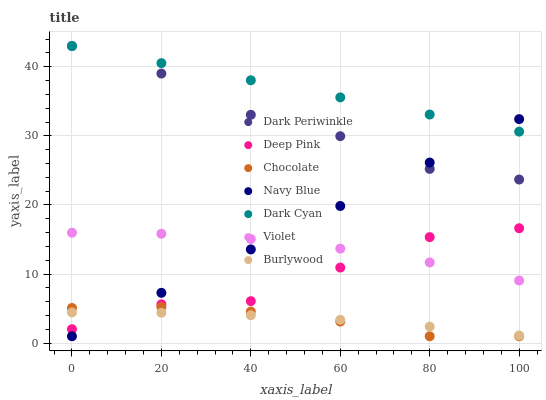Does Chocolate have the minimum area under the curve?
Answer yes or no. Yes. Does Dark Cyan have the maximum area under the curve?
Answer yes or no. Yes. Does Burlywood have the minimum area under the curve?
Answer yes or no. No. Does Burlywood have the maximum area under the curve?
Answer yes or no. No. Is Dark Cyan the smoothest?
Answer yes or no. Yes. Is Deep Pink the roughest?
Answer yes or no. Yes. Is Burlywood the smoothest?
Answer yes or no. No. Is Burlywood the roughest?
Answer yes or no. No. Does Navy Blue have the lowest value?
Answer yes or no. Yes. Does Burlywood have the lowest value?
Answer yes or no. No. Does Dark Periwinkle have the highest value?
Answer yes or no. Yes. Does Navy Blue have the highest value?
Answer yes or no. No. Is Burlywood less than Dark Cyan?
Answer yes or no. Yes. Is Dark Cyan greater than Violet?
Answer yes or no. Yes. Does Dark Cyan intersect Navy Blue?
Answer yes or no. Yes. Is Dark Cyan less than Navy Blue?
Answer yes or no. No. Is Dark Cyan greater than Navy Blue?
Answer yes or no. No. Does Burlywood intersect Dark Cyan?
Answer yes or no. No. 